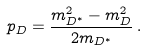<formula> <loc_0><loc_0><loc_500><loc_500>p _ { D } = \frac { m _ { D ^ { * } } ^ { 2 } - m _ { D } ^ { 2 } } { 2 m _ { D ^ { * } } } \, .</formula> 